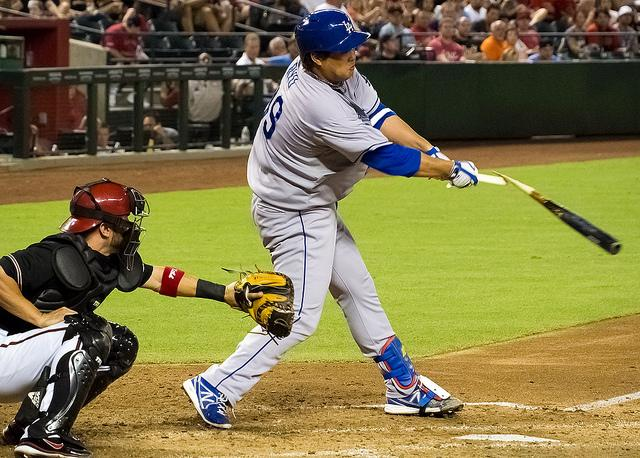What team is the batter playing for?

Choices:
A) red sox
B) orioles
C) dodgers
D) yankees dodgers 